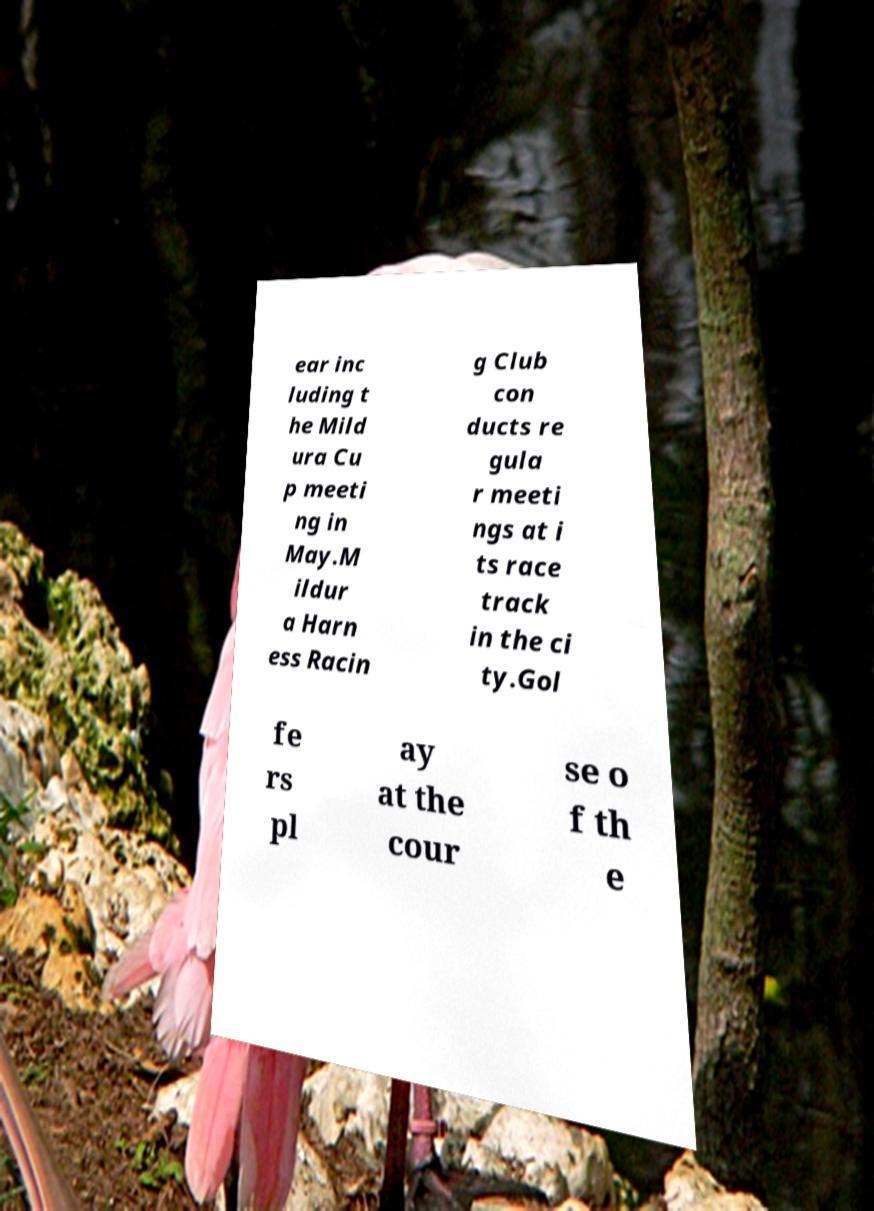Could you assist in decoding the text presented in this image and type it out clearly? ear inc luding t he Mild ura Cu p meeti ng in May.M ildur a Harn ess Racin g Club con ducts re gula r meeti ngs at i ts race track in the ci ty.Gol fe rs pl ay at the cour se o f th e 